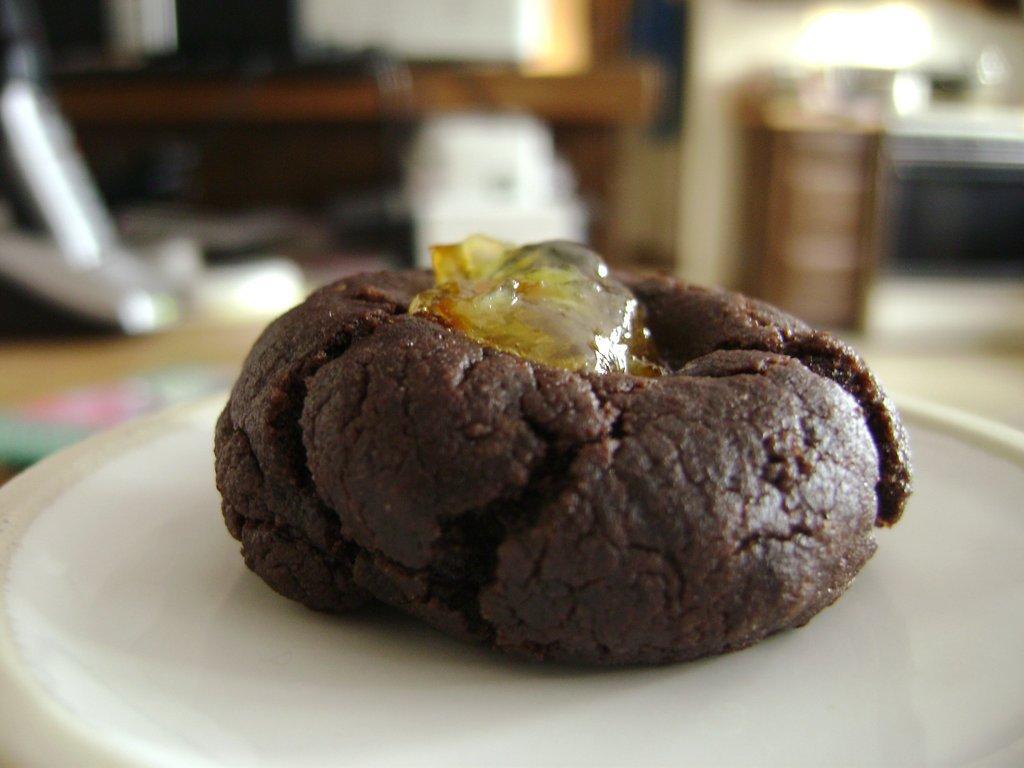Please provide a concise description of this image. Here we can see a food item on a plate. In the background the image is blur but we can see objects,wall and floor. 